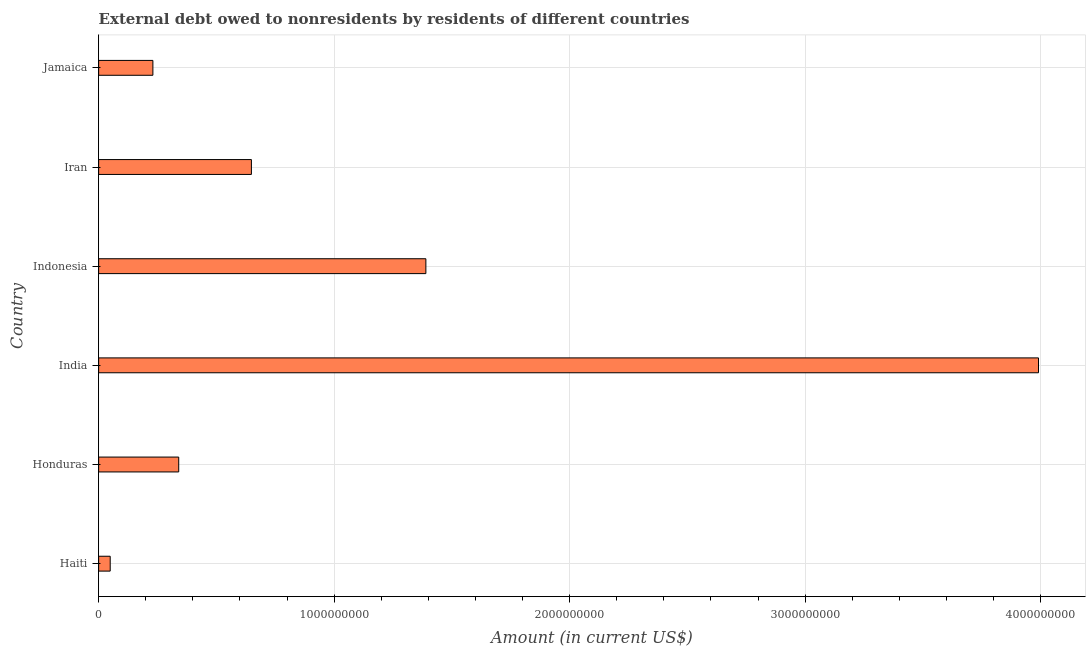Does the graph contain any zero values?
Ensure brevity in your answer.  No. Does the graph contain grids?
Ensure brevity in your answer.  Yes. What is the title of the graph?
Keep it short and to the point. External debt owed to nonresidents by residents of different countries. What is the label or title of the X-axis?
Give a very brief answer. Amount (in current US$). What is the label or title of the Y-axis?
Your answer should be very brief. Country. What is the debt in Jamaica?
Your response must be concise. 2.30e+08. Across all countries, what is the maximum debt?
Make the answer very short. 3.99e+09. Across all countries, what is the minimum debt?
Provide a short and direct response. 4.91e+07. In which country was the debt minimum?
Make the answer very short. Haiti. What is the sum of the debt?
Make the answer very short. 6.65e+09. What is the difference between the debt in India and Jamaica?
Offer a very short reply. 3.76e+09. What is the average debt per country?
Your answer should be very brief. 1.11e+09. What is the median debt?
Provide a short and direct response. 4.94e+08. In how many countries, is the debt greater than 1000000000 US$?
Your answer should be very brief. 2. What is the ratio of the debt in India to that in Jamaica?
Provide a succinct answer. 17.32. Is the debt in India less than that in Iran?
Your response must be concise. No. Is the difference between the debt in Honduras and India greater than the difference between any two countries?
Keep it short and to the point. No. What is the difference between the highest and the second highest debt?
Your answer should be compact. 2.60e+09. Is the sum of the debt in Haiti and India greater than the maximum debt across all countries?
Your response must be concise. Yes. What is the difference between the highest and the lowest debt?
Offer a terse response. 3.94e+09. In how many countries, is the debt greater than the average debt taken over all countries?
Offer a terse response. 2. Are all the bars in the graph horizontal?
Ensure brevity in your answer.  Yes. How many countries are there in the graph?
Provide a succinct answer. 6. What is the difference between two consecutive major ticks on the X-axis?
Offer a terse response. 1.00e+09. What is the Amount (in current US$) of Haiti?
Your answer should be compact. 4.91e+07. What is the Amount (in current US$) of Honduras?
Keep it short and to the point. 3.40e+08. What is the Amount (in current US$) in India?
Provide a succinct answer. 3.99e+09. What is the Amount (in current US$) in Indonesia?
Provide a short and direct response. 1.39e+09. What is the Amount (in current US$) of Iran?
Offer a terse response. 6.49e+08. What is the Amount (in current US$) in Jamaica?
Your answer should be very brief. 2.30e+08. What is the difference between the Amount (in current US$) in Haiti and Honduras?
Offer a very short reply. -2.91e+08. What is the difference between the Amount (in current US$) in Haiti and India?
Your answer should be compact. -3.94e+09. What is the difference between the Amount (in current US$) in Haiti and Indonesia?
Keep it short and to the point. -1.34e+09. What is the difference between the Amount (in current US$) in Haiti and Iran?
Offer a very short reply. -6.00e+08. What is the difference between the Amount (in current US$) in Haiti and Jamaica?
Offer a very short reply. -1.81e+08. What is the difference between the Amount (in current US$) in Honduras and India?
Ensure brevity in your answer.  -3.65e+09. What is the difference between the Amount (in current US$) in Honduras and Indonesia?
Keep it short and to the point. -1.05e+09. What is the difference between the Amount (in current US$) in Honduras and Iran?
Keep it short and to the point. -3.09e+08. What is the difference between the Amount (in current US$) in Honduras and Jamaica?
Provide a short and direct response. 1.10e+08. What is the difference between the Amount (in current US$) in India and Indonesia?
Provide a succinct answer. 2.60e+09. What is the difference between the Amount (in current US$) in India and Iran?
Keep it short and to the point. 3.34e+09. What is the difference between the Amount (in current US$) in India and Jamaica?
Provide a short and direct response. 3.76e+09. What is the difference between the Amount (in current US$) in Indonesia and Iran?
Offer a terse response. 7.41e+08. What is the difference between the Amount (in current US$) in Indonesia and Jamaica?
Ensure brevity in your answer.  1.16e+09. What is the difference between the Amount (in current US$) in Iran and Jamaica?
Give a very brief answer. 4.18e+08. What is the ratio of the Amount (in current US$) in Haiti to that in Honduras?
Provide a short and direct response. 0.14. What is the ratio of the Amount (in current US$) in Haiti to that in India?
Offer a very short reply. 0.01. What is the ratio of the Amount (in current US$) in Haiti to that in Indonesia?
Your answer should be very brief. 0.04. What is the ratio of the Amount (in current US$) in Haiti to that in Iran?
Provide a succinct answer. 0.08. What is the ratio of the Amount (in current US$) in Haiti to that in Jamaica?
Your answer should be compact. 0.21. What is the ratio of the Amount (in current US$) in Honduras to that in India?
Ensure brevity in your answer.  0.09. What is the ratio of the Amount (in current US$) in Honduras to that in Indonesia?
Ensure brevity in your answer.  0.24. What is the ratio of the Amount (in current US$) in Honduras to that in Iran?
Keep it short and to the point. 0.52. What is the ratio of the Amount (in current US$) in Honduras to that in Jamaica?
Offer a very short reply. 1.48. What is the ratio of the Amount (in current US$) in India to that in Indonesia?
Provide a short and direct response. 2.87. What is the ratio of the Amount (in current US$) in India to that in Iran?
Ensure brevity in your answer.  6.15. What is the ratio of the Amount (in current US$) in India to that in Jamaica?
Ensure brevity in your answer.  17.32. What is the ratio of the Amount (in current US$) in Indonesia to that in Iran?
Your response must be concise. 2.14. What is the ratio of the Amount (in current US$) in Indonesia to that in Jamaica?
Give a very brief answer. 6.03. What is the ratio of the Amount (in current US$) in Iran to that in Jamaica?
Make the answer very short. 2.81. 